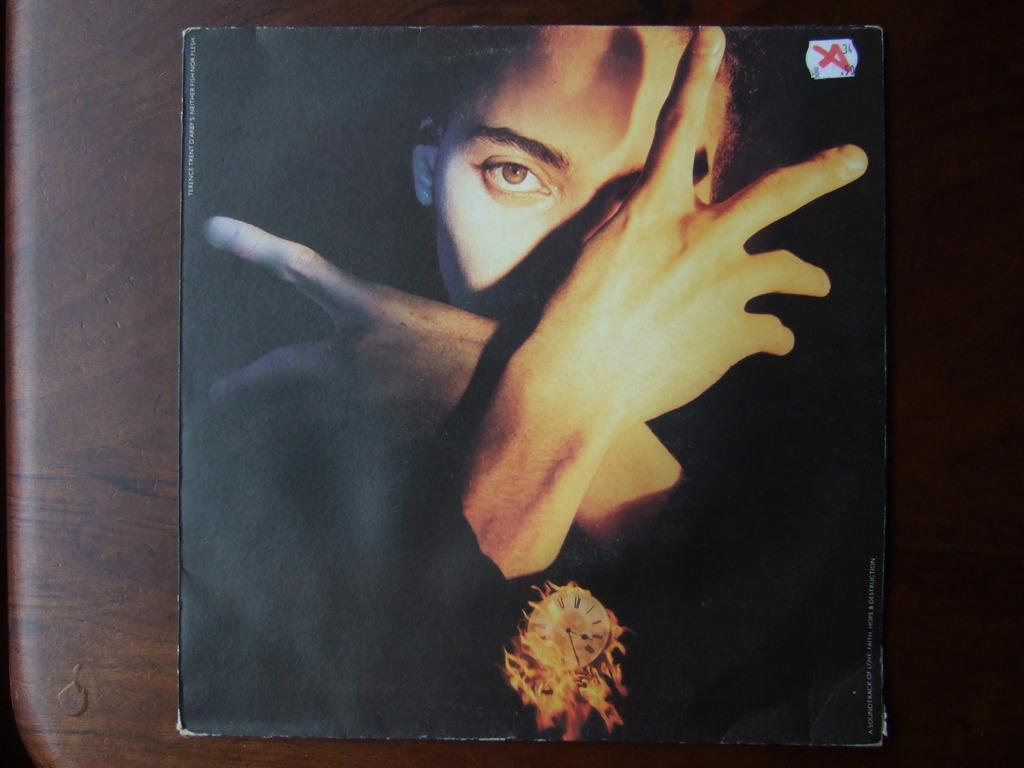What is depicted on the cover page of the book? There is a person's picture on the cover page of the book. What is the color of the surface on which the cover page is placed? The cover page is on a brown color surface. Is the person in the picture driving a pump in the image? There is no pump or driving activity present in the image; it only features a person's picture on the cover page of a book. 